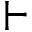<formula> <loc_0><loc_0><loc_500><loc_500>\vdash</formula> 